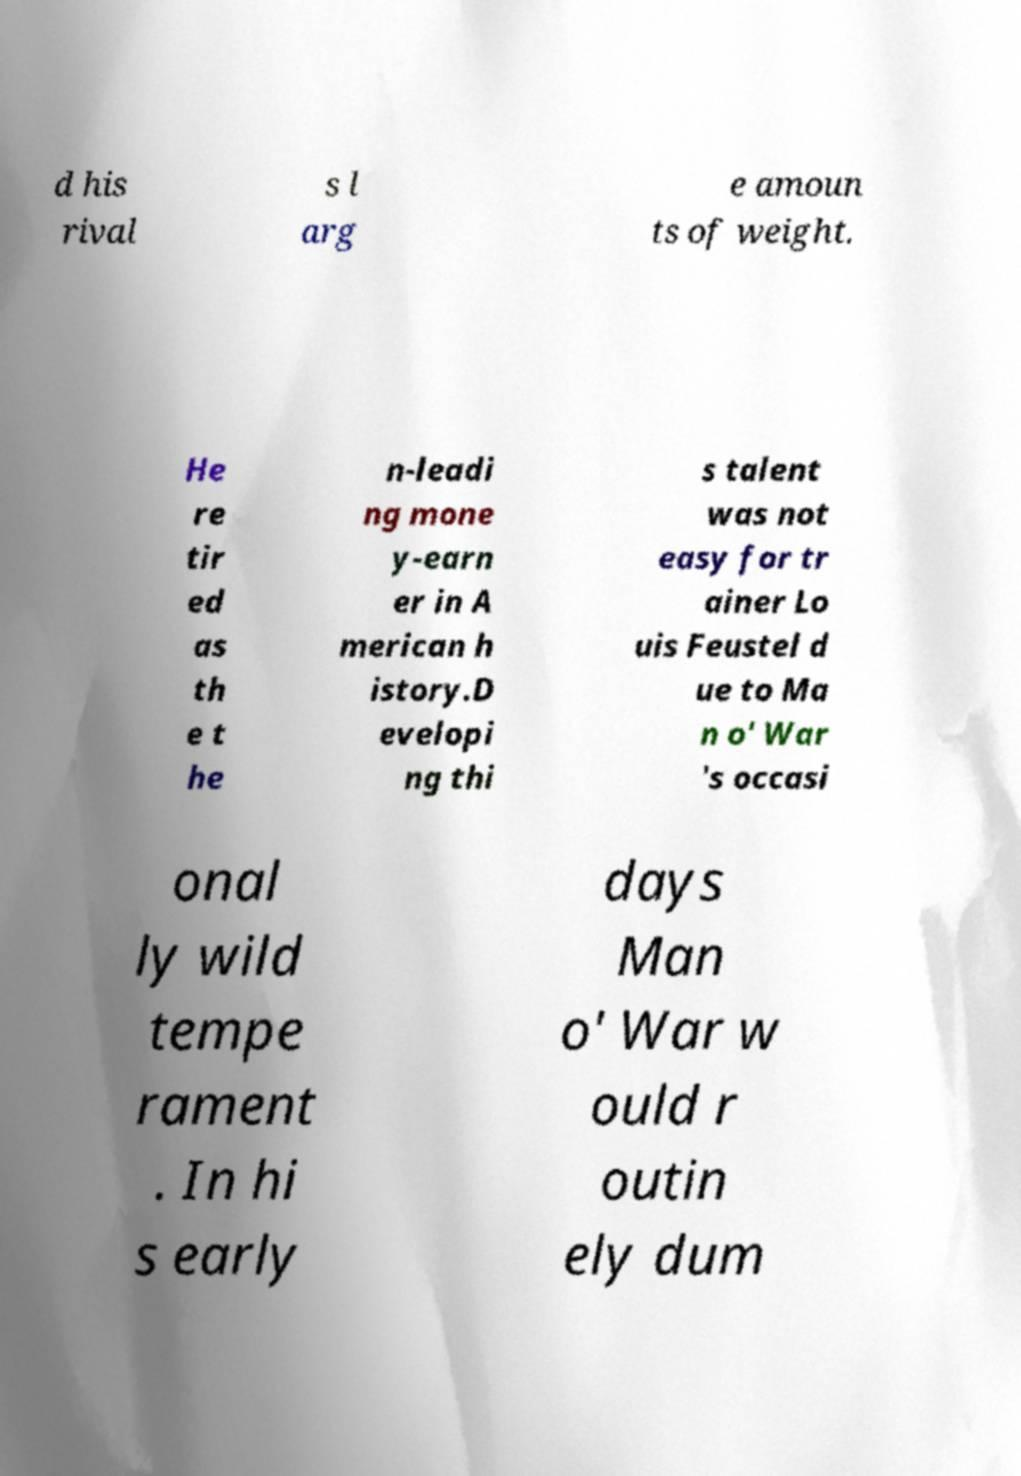There's text embedded in this image that I need extracted. Can you transcribe it verbatim? d his rival s l arg e amoun ts of weight. He re tir ed as th e t he n-leadi ng mone y-earn er in A merican h istory.D evelopi ng thi s talent was not easy for tr ainer Lo uis Feustel d ue to Ma n o' War 's occasi onal ly wild tempe rament . In hi s early days Man o' War w ould r outin ely dum 